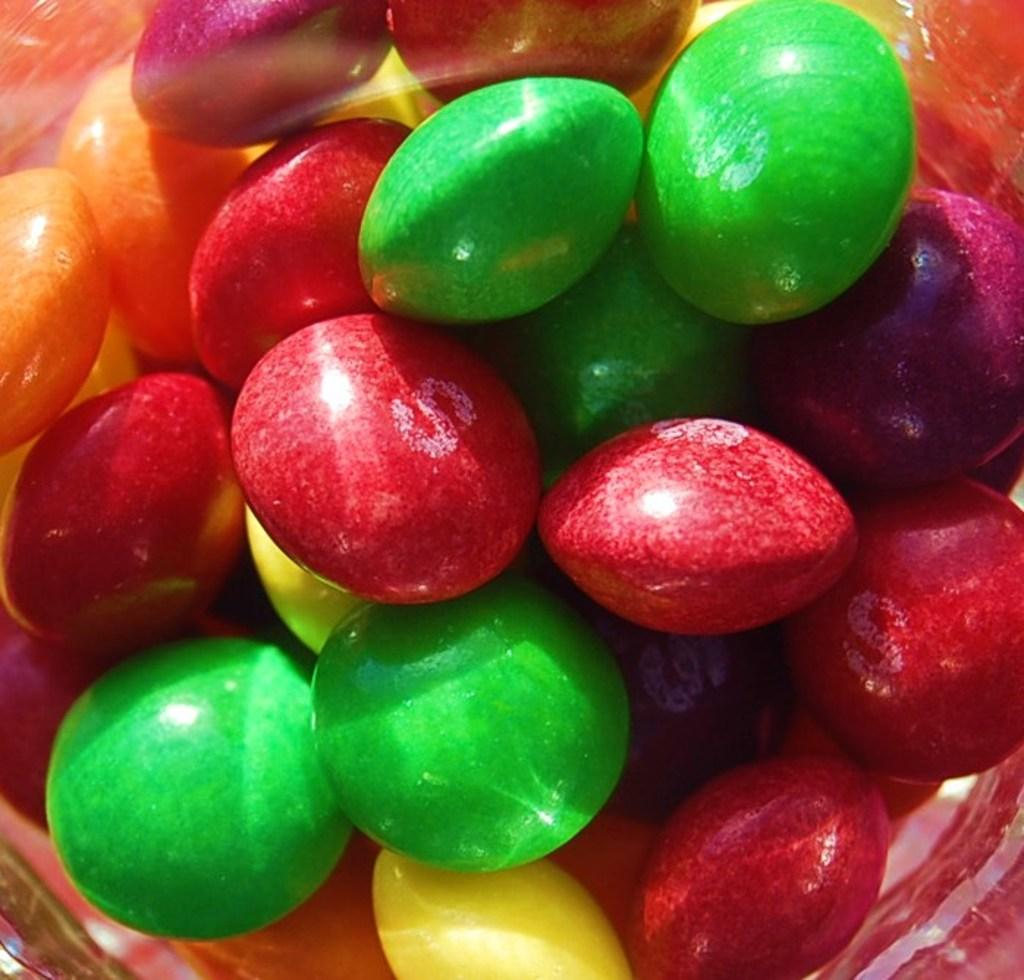What type of objects are present in the image? There are colorful gems in the image. Can you describe any specific details about the gems? The letter 'S' is visible on some of the gems. Can you touch the gems in the image? You cannot touch the gems in the image, as it is a two-dimensional representation. Is there a hill visible in the image? There is no hill present in the image; it only features colorful gems. 